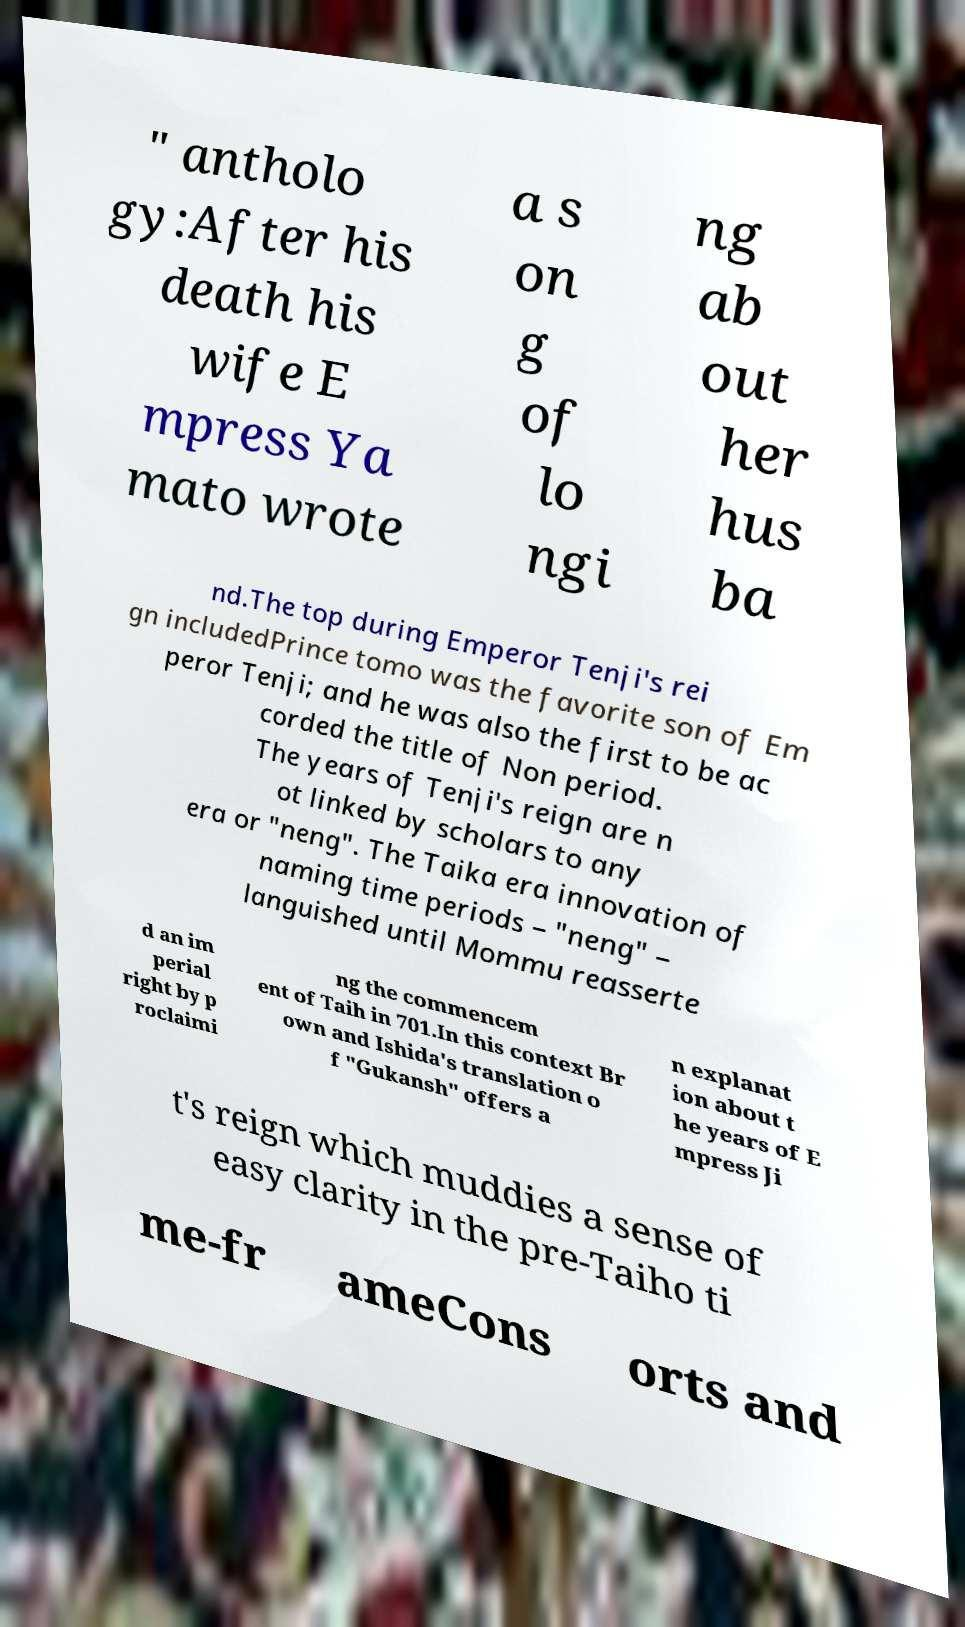Please read and relay the text visible in this image. What does it say? " antholo gy:After his death his wife E mpress Ya mato wrote a s on g of lo ngi ng ab out her hus ba nd.The top during Emperor Tenji's rei gn includedPrince tomo was the favorite son of Em peror Tenji; and he was also the first to be ac corded the title of Non period. The years of Tenji's reign are n ot linked by scholars to any era or "neng". The Taika era innovation of naming time periods – "neng" – languished until Mommu reasserte d an im perial right by p roclaimi ng the commencem ent of Taih in 701.In this context Br own and Ishida's translation o f "Gukansh" offers a n explanat ion about t he years of E mpress Ji t's reign which muddies a sense of easy clarity in the pre-Taiho ti me-fr ameCons orts and 